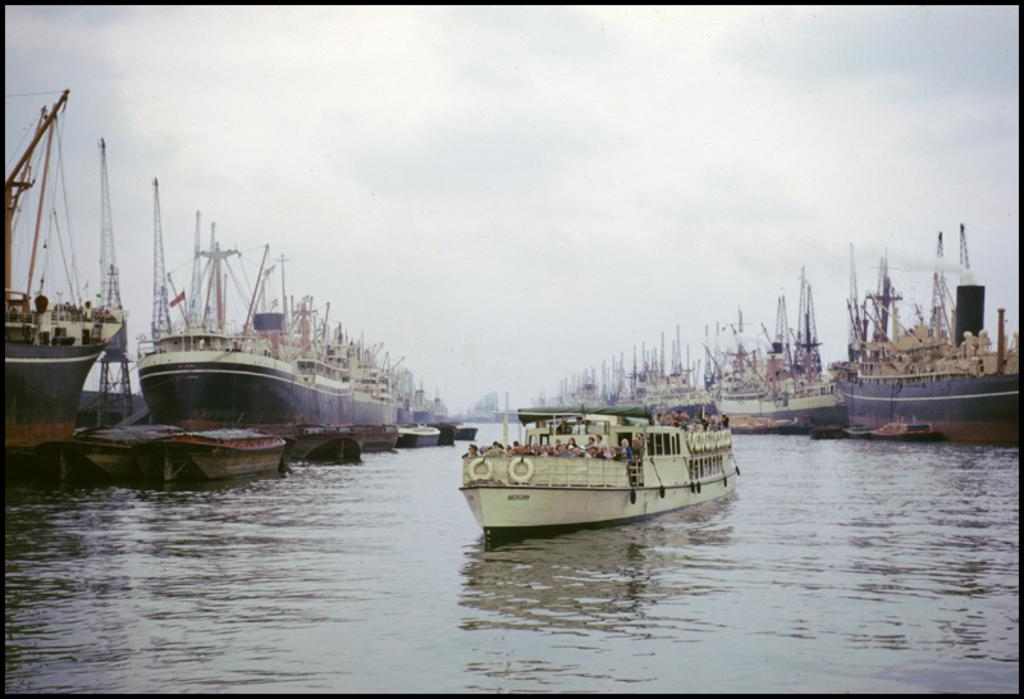What is the arrangement of the ships in the image? There are ships standing on the water in a row on the two sides, with a ship in the middle. What is happening in the middle ship? People are sitting in the middle ship. Can you see any ducks swimming near the ships in the image? There is no mention of ducks in the provided facts, so we cannot determine if any are present in the image. 